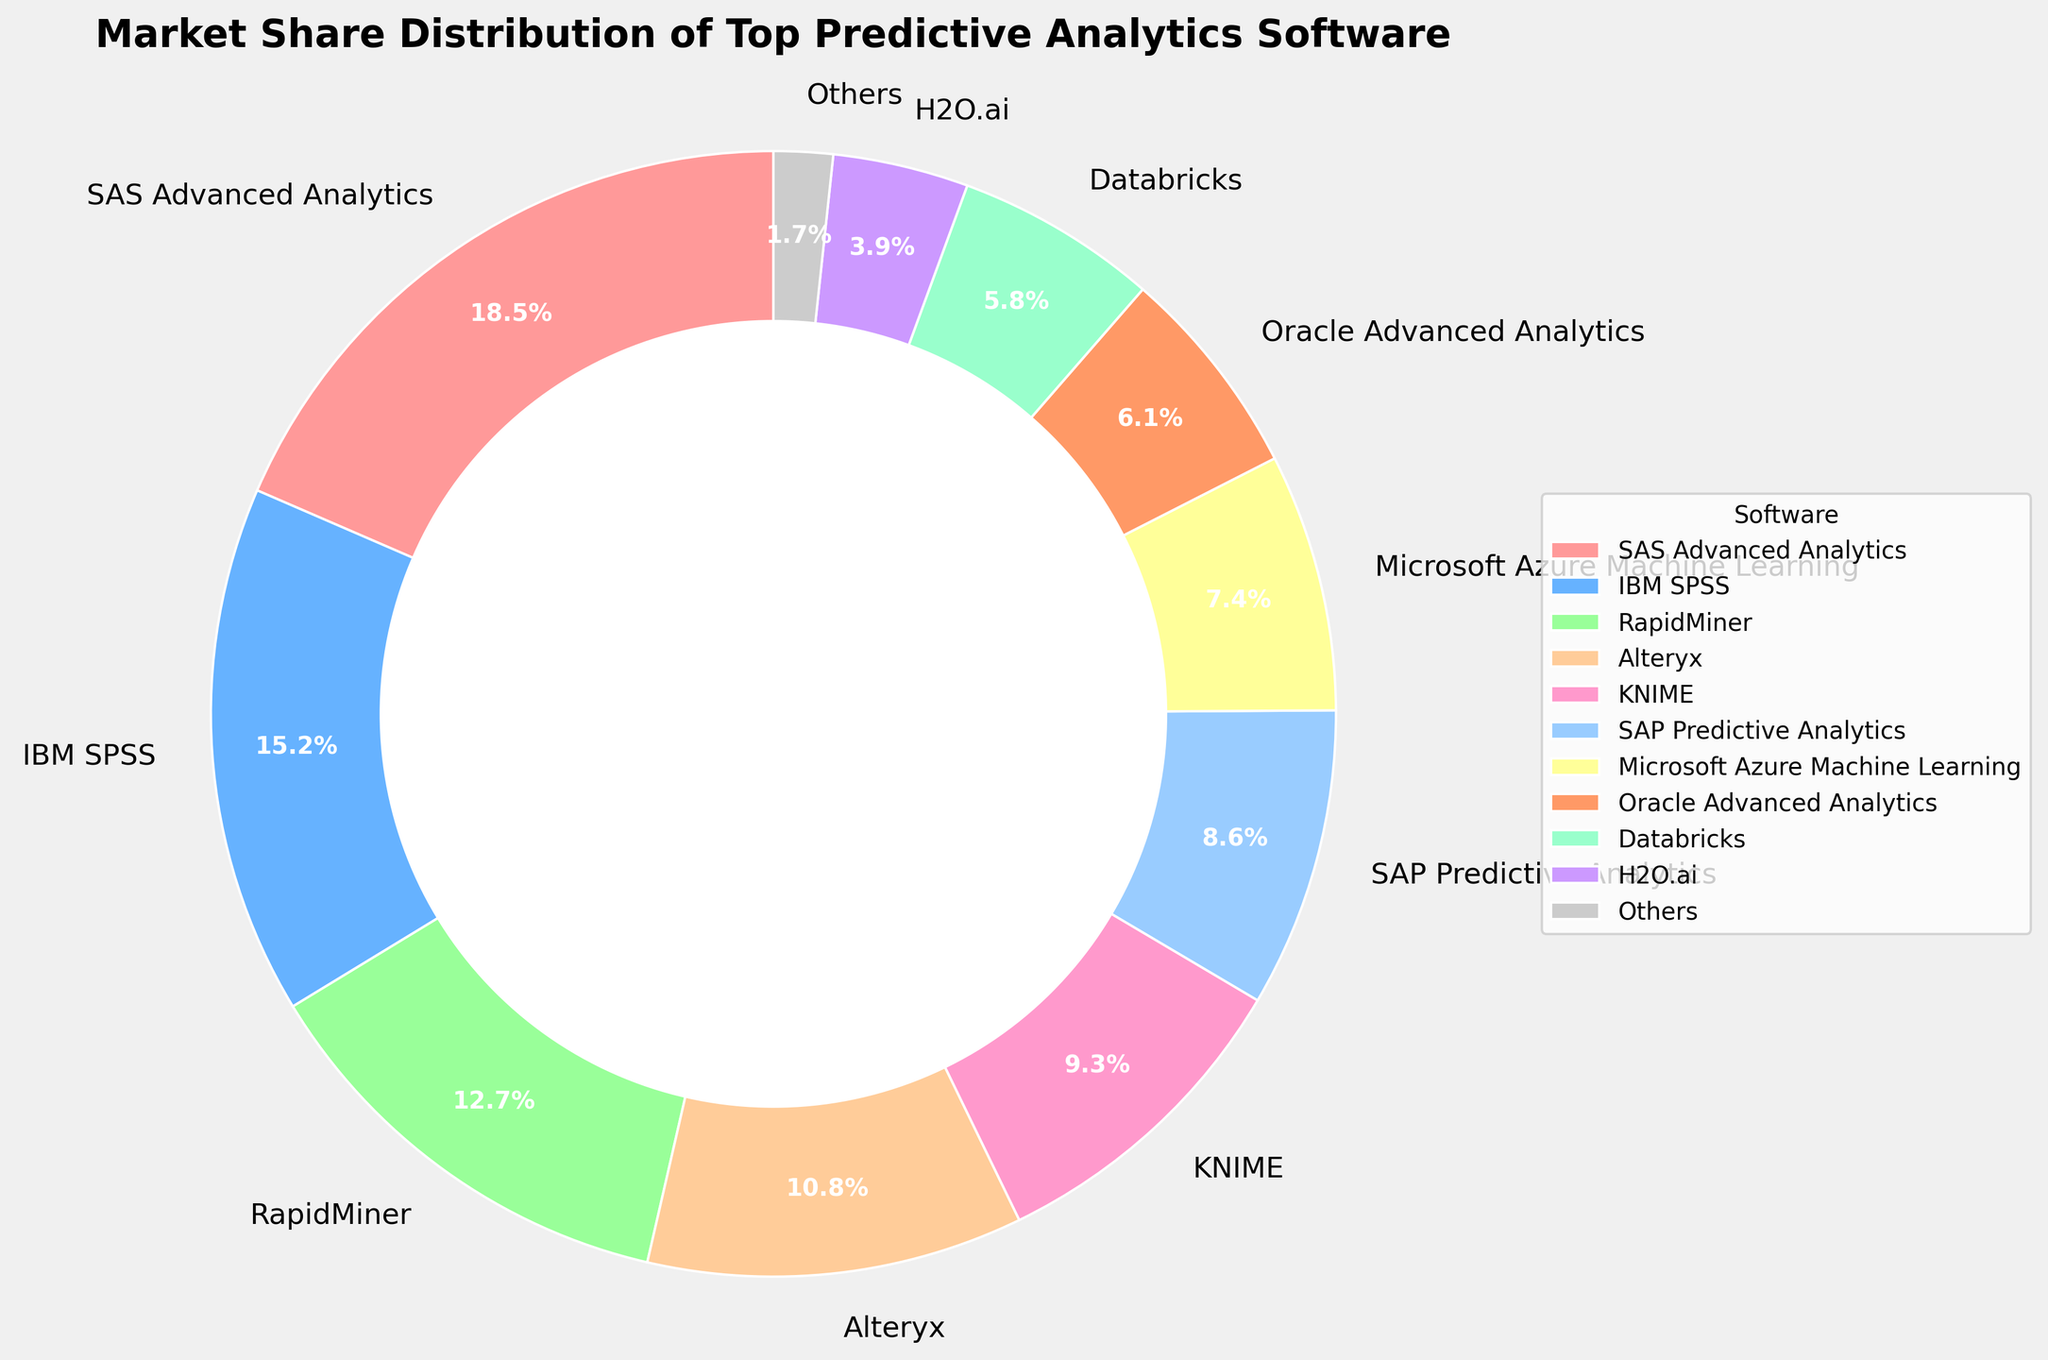Which software holds the largest market share? The chart indicates the market share for each software by segment size. The largest segment corresponds to SAS Advanced Analytics with 18.5%.
Answer: SAS Advanced Analytics What is the combined market share of the top three software? The top three software are SAS Advanced Analytics (18.5%), IBM SPSS (15.2%), and RapidMiner (12.7%). Adding these together yields 18.5 + 15.2 + 12.7 = 46.4%.
Answer: 46.4% Which software has a smaller market share: KNIME or SAP Predictive Analytics? By comparing the segment sizes for KNIME and SAP Predictive Analytics, KNIME has 9.3% while SAP Predictive Analytics has 8.6%. Hence, SAP Predictive Analytics has a smaller market share.
Answer: SAP Predictive Analytics How much larger is the market share of SAS Advanced Analytics compared to that of H2O.ai? The market share of SAS Advanced Analytics is 18.5%, and that of H2O.ai is 3.9%. The difference is 18.5 - 3.9 = 14.6%.
Answer: 14.6% What is the total market share of software that have less than 10% each? The software with less than 10% market share are Alteryx (10.8% not included), KNIME (9.3%), SAP Predictive Analytics (8.6%), Microsoft Azure Machine Learning (7.4%), Oracle Advanced Analytics (6.1%), Databricks (5.8%), H2O.ai (3.9%), and Others (1.7%). Summing these gives 9.3 + 8.6 + 7.4 + 6.1 + 5.8 + 3.9 + 1.7 = 42.8%.
Answer: 42.8% Do any two software segments appear visually equal in market share? By examining the chart, no two segments appear visually equal in market share based on their size and labels.
Answer: No What is the average market share of Microsoft Azure Machine Learning, Oracle Advanced Analytics, and Databricks? The market shares are Microsoft Azure Machine Learning (7.4%), Oracle Advanced Analytics (6.1%), and Databricks (5.8%). Calculating the average: (7.4 + 6.1 + 5.8) / 3 = 6.43%.
Answer: 6.43% Which software segment is represented by the light blue color? By observing the colors used in the chart, IBM SPSS is represented by the light blue color and holds a 15.2% market share.
Answer: IBM SPSS 